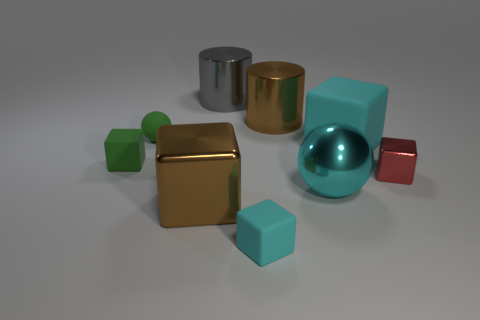What's the texture of the objects like? The objects exhibit a variety of textures. The cubes and the sphere have a smooth, almost polished look, while the cylinder's surface seems to have a more matte finish. The differences in texture between the shiny and less reflective surfaces add depth and visual interest to the image. 